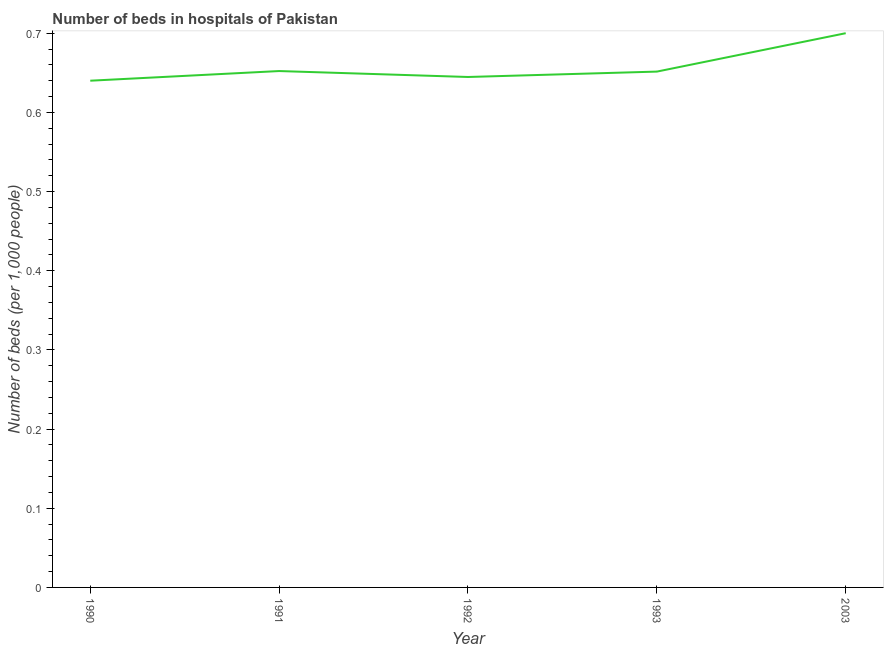What is the number of hospital beds in 1993?
Offer a terse response. 0.65. Across all years, what is the minimum number of hospital beds?
Ensure brevity in your answer.  0.64. In which year was the number of hospital beds minimum?
Give a very brief answer. 1990. What is the sum of the number of hospital beds?
Give a very brief answer. 3.29. What is the difference between the number of hospital beds in 1990 and 1992?
Ensure brevity in your answer.  -0. What is the average number of hospital beds per year?
Ensure brevity in your answer.  0.66. What is the median number of hospital beds?
Give a very brief answer. 0.65. Do a majority of the years between 1990 and 1991 (inclusive) have number of hospital beds greater than 0.6600000000000001 %?
Offer a terse response. No. What is the ratio of the number of hospital beds in 1990 to that in 1993?
Your answer should be very brief. 0.98. What is the difference between the highest and the second highest number of hospital beds?
Provide a succinct answer. 0.05. Is the sum of the number of hospital beds in 1990 and 2003 greater than the maximum number of hospital beds across all years?
Make the answer very short. Yes. What is the difference between the highest and the lowest number of hospital beds?
Make the answer very short. 0.06. In how many years, is the number of hospital beds greater than the average number of hospital beds taken over all years?
Offer a terse response. 1. Does the number of hospital beds monotonically increase over the years?
Provide a short and direct response. No. How many lines are there?
Offer a terse response. 1. How many years are there in the graph?
Your response must be concise. 5. Does the graph contain grids?
Make the answer very short. No. What is the title of the graph?
Make the answer very short. Number of beds in hospitals of Pakistan. What is the label or title of the X-axis?
Make the answer very short. Year. What is the label or title of the Y-axis?
Offer a terse response. Number of beds (per 1,0 people). What is the Number of beds (per 1,000 people) of 1990?
Your answer should be very brief. 0.64. What is the Number of beds (per 1,000 people) of 1991?
Give a very brief answer. 0.65. What is the Number of beds (per 1,000 people) of 1992?
Make the answer very short. 0.64. What is the Number of beds (per 1,000 people) in 1993?
Provide a short and direct response. 0.65. What is the Number of beds (per 1,000 people) of 2003?
Your answer should be very brief. 0.7. What is the difference between the Number of beds (per 1,000 people) in 1990 and 1991?
Keep it short and to the point. -0.01. What is the difference between the Number of beds (per 1,000 people) in 1990 and 1992?
Provide a short and direct response. -0. What is the difference between the Number of beds (per 1,000 people) in 1990 and 1993?
Your answer should be compact. -0.01. What is the difference between the Number of beds (per 1,000 people) in 1990 and 2003?
Your answer should be very brief. -0.06. What is the difference between the Number of beds (per 1,000 people) in 1991 and 1992?
Offer a very short reply. 0.01. What is the difference between the Number of beds (per 1,000 people) in 1991 and 1993?
Offer a terse response. 0. What is the difference between the Number of beds (per 1,000 people) in 1991 and 2003?
Ensure brevity in your answer.  -0.05. What is the difference between the Number of beds (per 1,000 people) in 1992 and 1993?
Offer a terse response. -0.01. What is the difference between the Number of beds (per 1,000 people) in 1992 and 2003?
Provide a short and direct response. -0.06. What is the difference between the Number of beds (per 1,000 people) in 1993 and 2003?
Offer a terse response. -0.05. What is the ratio of the Number of beds (per 1,000 people) in 1990 to that in 1991?
Your response must be concise. 0.98. What is the ratio of the Number of beds (per 1,000 people) in 1990 to that in 1992?
Your answer should be very brief. 0.99. What is the ratio of the Number of beds (per 1,000 people) in 1990 to that in 2003?
Provide a succinct answer. 0.91. What is the ratio of the Number of beds (per 1,000 people) in 1991 to that in 1992?
Your answer should be compact. 1.01. What is the ratio of the Number of beds (per 1,000 people) in 1991 to that in 1993?
Give a very brief answer. 1. What is the ratio of the Number of beds (per 1,000 people) in 1991 to that in 2003?
Provide a short and direct response. 0.93. What is the ratio of the Number of beds (per 1,000 people) in 1992 to that in 2003?
Offer a very short reply. 0.92. 